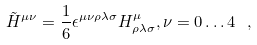Convert formula to latex. <formula><loc_0><loc_0><loc_500><loc_500>\tilde { H } ^ { \mu \nu } = \frac { 1 } { 6 } \epsilon ^ { \mu \nu \rho \lambda \sigma } H _ { \rho \lambda \sigma } ^ { \mu } , \nu = 0 \dots 4 \ ,</formula> 